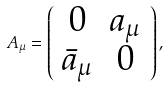Convert formula to latex. <formula><loc_0><loc_0><loc_500><loc_500>A _ { \mu } = \left ( \begin{array} { c c c } 0 & a _ { \mu } \\ \bar { a } _ { \mu } & 0 \\ \end{array} \right ) ,</formula> 